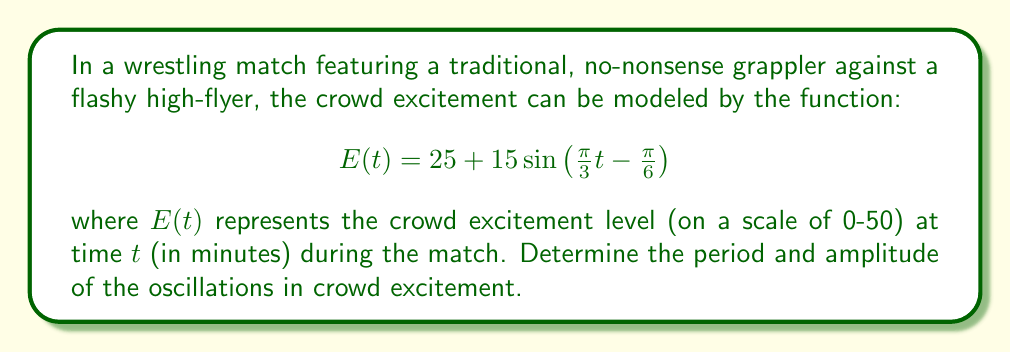Provide a solution to this math problem. To find the period and amplitude of the oscillations, we need to analyze the given function:

$$E(t) = 25 + 15\sin\left(\frac{\pi}{3}t - \frac{\pi}{6}\right)$$

1. Period:
   The period of a sine function is given by $T = \frac{2\pi}{|\omega|}$, where $\omega$ is the angular frequency.
   In this case, $\omega = \frac{\pi}{3}$
   
   Therefore, $T = \frac{2\pi}{|\frac{\pi}{3}|} = \frac{2\pi}{\frac{\pi}{3}} = 6$ minutes

2. Amplitude:
   The amplitude is the coefficient of the sine function.
   In this case, the amplitude is 15.

The function can be rewritten in the general form:
$$E(t) = A\sin(\omega t + \phi) + C$$

Where:
$A = 15$ (amplitude)
$\omega = \frac{\pi}{3}$ (angular frequency)
$\phi = -\frac{\pi}{6}$ (phase shift)
$C = 25$ (vertical shift)

The amplitude directly represents the maximum deviation from the mean excitement level of 25.
Answer: Period: 6 minutes, Amplitude: 15 